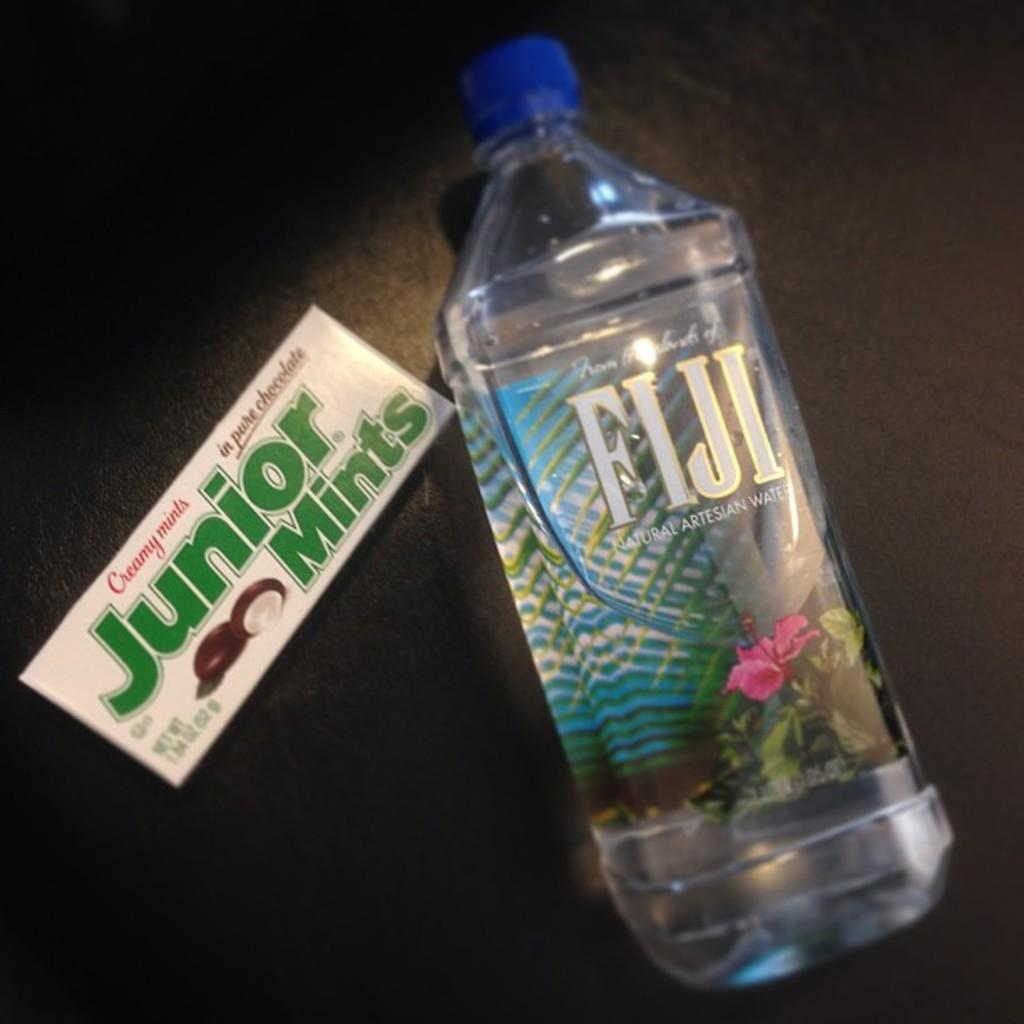What object can be seen in the image that contains a liquid? There is a bottle in the image, and it contains water. What else is present in the image besides the bottle? There is a card in the image. What type of key is used to open the bottle in the image? There is no key present in the image, and the bottle does not need to be opened as it is already filled with water. 